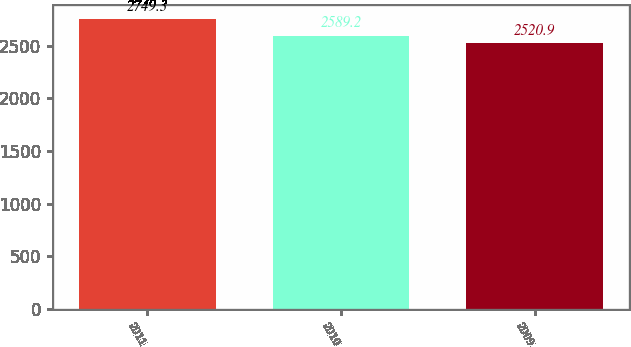Convert chart to OTSL. <chart><loc_0><loc_0><loc_500><loc_500><bar_chart><fcel>2011<fcel>2010<fcel>2009<nl><fcel>2749.3<fcel>2589.2<fcel>2520.9<nl></chart> 